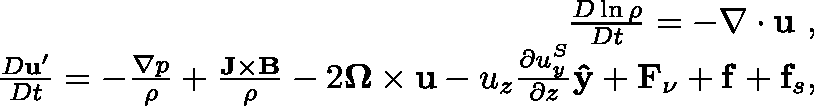<formula> <loc_0><loc_0><loc_500><loc_500>\begin{array} { r l r } & { \frac { D \ln \rho } { D t } = - \nabla \cdot u , } \\ & { \frac { D u ^ { \prime } } { D t } = - \frac { \nabla p } { \rho } + \frac { J \times B } { \rho } - 2 \Omega \times u - u _ { z } \frac { \partial u _ { y } ^ { S } } { \partial z } { \hat { y } } + F _ { \nu } + f + f _ { s } , } \end{array}</formula> 